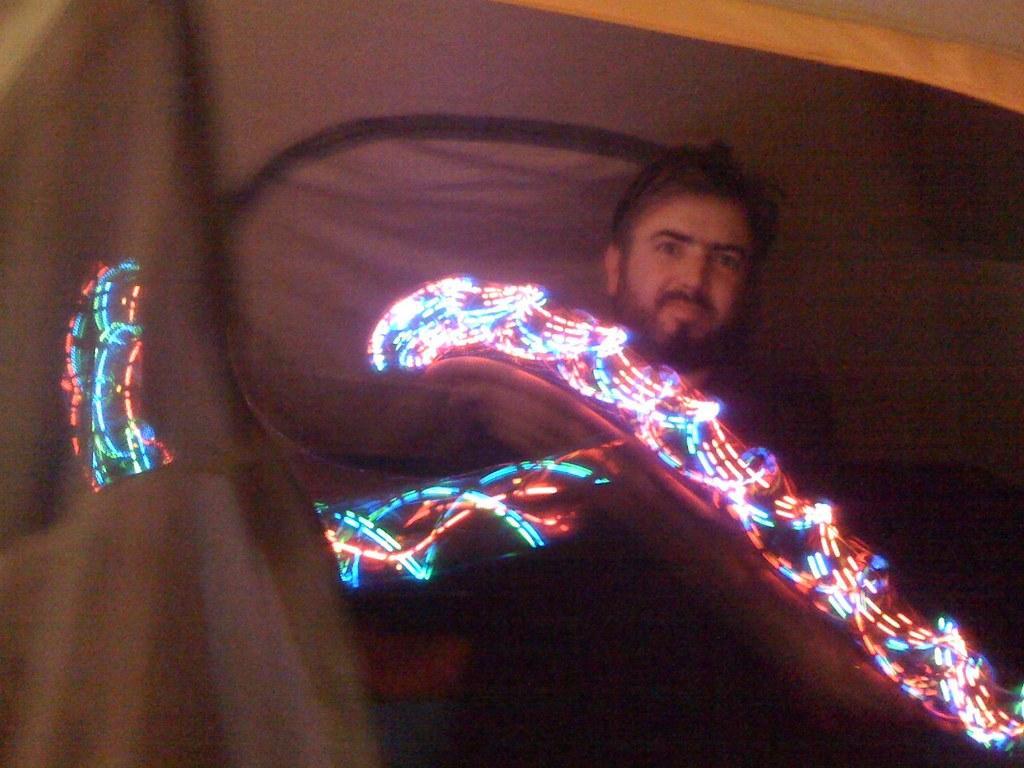In one or two sentences, can you explain what this image depicts? In the center of the picture there is a man standing. In the foreground there are lights. Behind the man there is a curtain. 